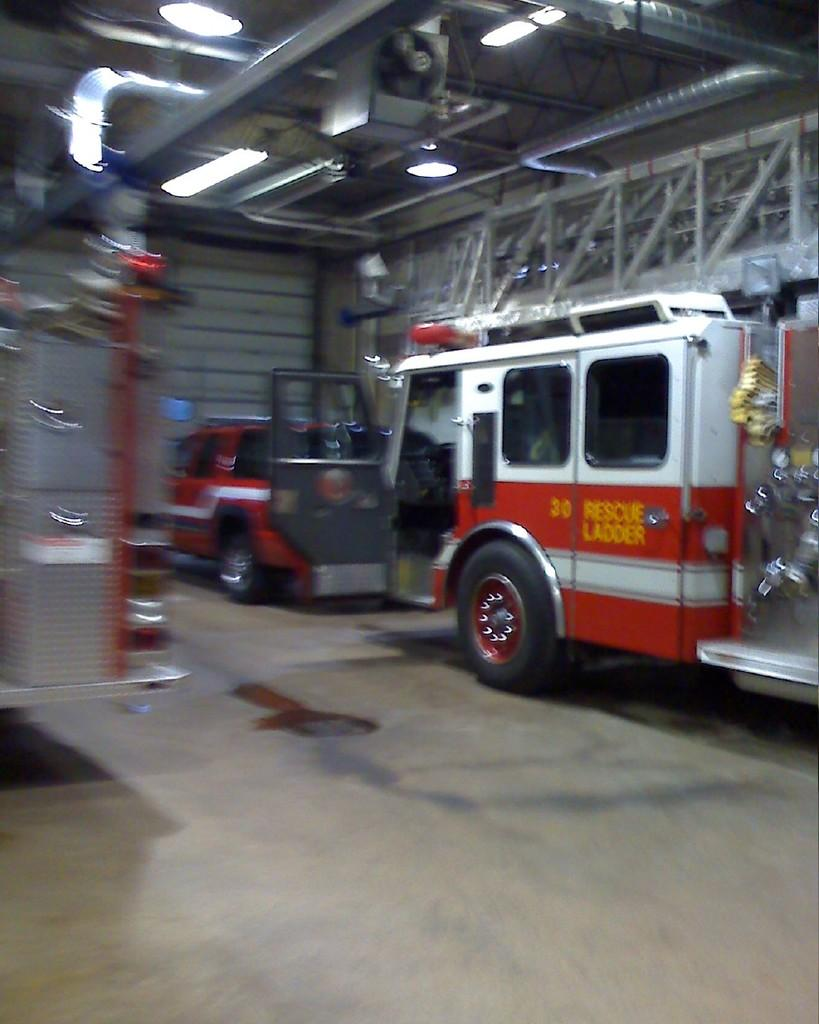What is located in the center of the image? There are vehicles in the center of the image. What structure can be seen at the top of the image? There is a roof visible at the top of the image. What feature is present at the top of the image along with the roof? Lights are present at the top of the image. What surface is visible at the bottom of the image? There is a floor visible at the bottom of the image. Can you tell me how many owls are sitting on the vehicles in the image? There are no owls present in the image; it features vehicles, a roof, lights, and a floor. What type of advertisement is displayed on the vehicles in the image? There is no advertisement visible on the vehicles in the image. 